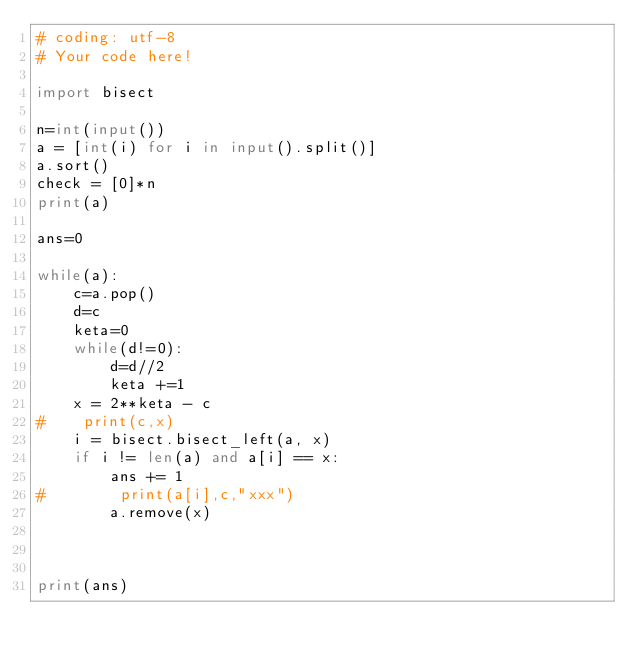<code> <loc_0><loc_0><loc_500><loc_500><_Python_># coding: utf-8
# Your code here!

import bisect

n=int(input())
a = [int(i) for i in input().split()]
a.sort()
check = [0]*n
print(a)

ans=0

while(a):
    c=a.pop()
    d=c
    keta=0
    while(d!=0):
        d=d//2
        keta +=1
    x = 2**keta - c
#    print(c,x)
    i = bisect.bisect_left(a, x)
    if i != len(a) and a[i] == x:
        ans += 1
#        print(a[i],c,"xxx")
        a.remove(x)



print(ans)

</code> 